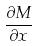Convert formula to latex. <formula><loc_0><loc_0><loc_500><loc_500>\frac { \partial M } { \partial x }</formula> 